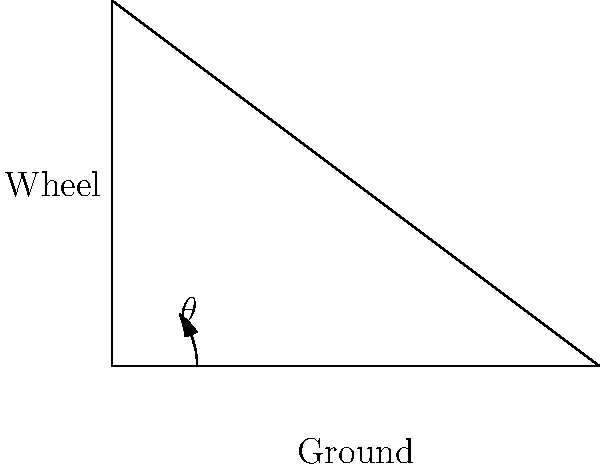In a classic Ferrari 250 GTO, the wheels are set with a negative camber angle for improved cornering performance. If the distance from the top of the wheel to the ground is 3 units, and the bottom of the wheel is 4 units away from the vertical line passing through the top of the wheel, what is the camber angle $\theta$ in degrees? To find the camber angle, we need to use trigonometry:

1) The wheel and ground form a right-angled triangle.
2) The vertical height (opposite side) is 3 units.
3) The horizontal distance (adjacent side) is 4 units.
4) We need to find the angle between the vertical line and the wheel centerline.
5) This is an inverse tangent (arctan) problem.
6) The tangent of the angle is the opposite divided by the adjacent:
   
   $\tan(\theta) = \frac{\text{opposite}}{\text{adjacent}} = \frac{4}{3}$

7) To find $\theta$, we take the inverse tangent (arctan) of this ratio:
   
   $\theta = \arctan(\frac{4}{3})$

8) Using a calculator or trigonometric tables:
   
   $\theta \approx 53.13°$

9) The camber angle is the complement of this angle:
   
   $\text{Camber angle} = 90° - 53.13° \approx 36.87°$

10) Rounding to the nearest degree: 37°
Answer: 37° 